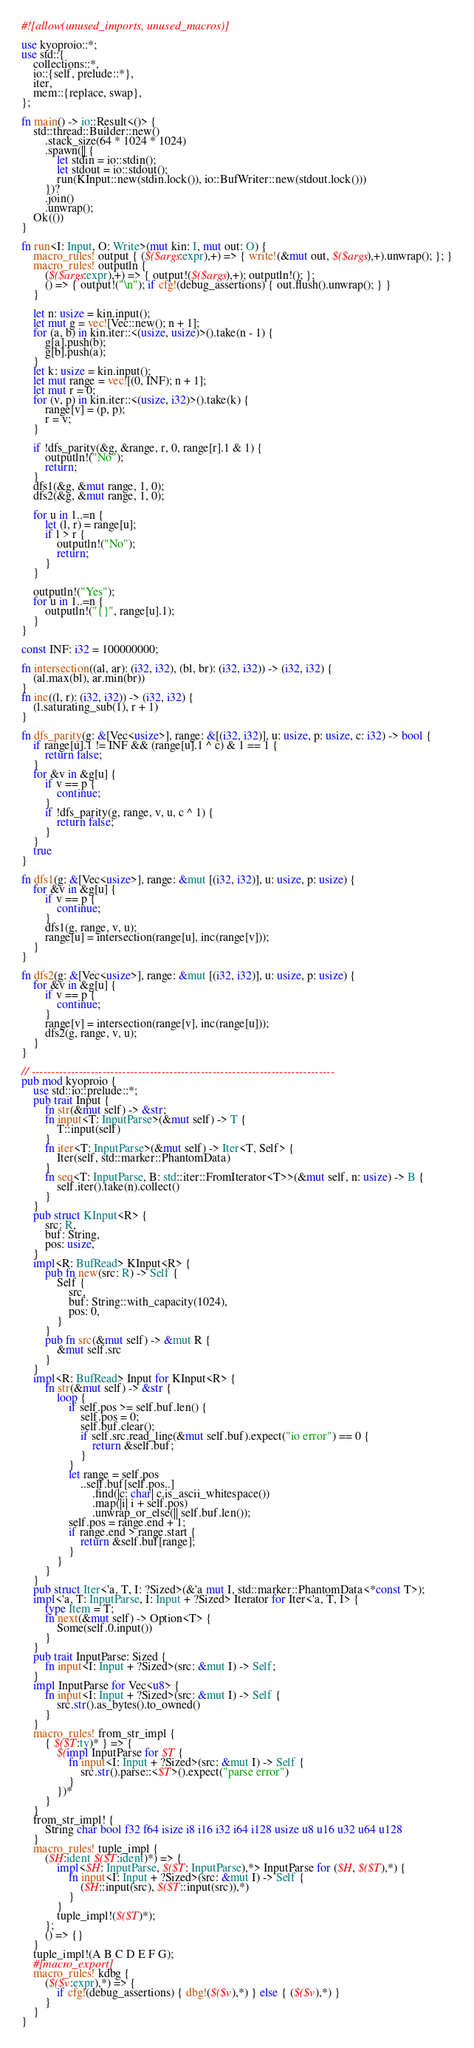Convert code to text. <code><loc_0><loc_0><loc_500><loc_500><_Rust_>#![allow(unused_imports, unused_macros)]

use kyoproio::*;
use std::{
    collections::*,
    io::{self, prelude::*},
    iter,
    mem::{replace, swap},
};

fn main() -> io::Result<()> {
    std::thread::Builder::new()
        .stack_size(64 * 1024 * 1024)
        .spawn(|| {
            let stdin = io::stdin();
            let stdout = io::stdout();
            run(KInput::new(stdin.lock()), io::BufWriter::new(stdout.lock()))
        })?
        .join()
        .unwrap();
    Ok(())
}

fn run<I: Input, O: Write>(mut kin: I, mut out: O) {
    macro_rules! output { ($($args:expr),+) => { write!(&mut out, $($args),+).unwrap(); }; }
    macro_rules! outputln {
        ($($args:expr),+) => { output!($($args),+); outputln!(); };
        () => { output!("\n"); if cfg!(debug_assertions) { out.flush().unwrap(); } }
    }

    let n: usize = kin.input();
    let mut g = vec![Vec::new(); n + 1];
    for (a, b) in kin.iter::<(usize, usize)>().take(n - 1) {
        g[a].push(b);
        g[b].push(a);
    }
    let k: usize = kin.input();
    let mut range = vec![(0, INF); n + 1];
    let mut r = 0;
    for (v, p) in kin.iter::<(usize, i32)>().take(k) {
        range[v] = (p, p);
        r = v;
    }

    if !dfs_parity(&g, &range, r, 0, range[r].1 & 1) {
        outputln!("No");
        return;
    }
    dfs1(&g, &mut range, 1, 0);
    dfs2(&g, &mut range, 1, 0);

    for u in 1..=n {
        let (l, r) = range[u];
        if l > r {
            outputln!("No");
            return;
        }
    }

    outputln!("Yes");
    for u in 1..=n {
        outputln!("{}", range[u].1);
    }
}

const INF: i32 = 100000000;

fn intersection((al, ar): (i32, i32), (bl, br): (i32, i32)) -> (i32, i32) {
    (al.max(bl), ar.min(br))
}
fn inc((l, r): (i32, i32)) -> (i32, i32) {
    (l.saturating_sub(1), r + 1)
}

fn dfs_parity(g: &[Vec<usize>], range: &[(i32, i32)], u: usize, p: usize, c: i32) -> bool {
    if range[u].1 != INF && (range[u].1 ^ c) & 1 == 1 {
        return false;
    }
    for &v in &g[u] {
        if v == p {
            continue;
        }
        if !dfs_parity(g, range, v, u, c ^ 1) {
            return false;
        }
    }
    true
}

fn dfs1(g: &[Vec<usize>], range: &mut [(i32, i32)], u: usize, p: usize) {
    for &v in &g[u] {
        if v == p {
            continue;
        }
        dfs1(g, range, v, u);
        range[u] = intersection(range[u], inc(range[v]));
    }
}

fn dfs2(g: &[Vec<usize>], range: &mut [(i32, i32)], u: usize, p: usize) {
    for &v in &g[u] {
        if v == p {
            continue;
        }
        range[v] = intersection(range[v], inc(range[u]));
        dfs2(g, range, v, u);
    }
}

// -----------------------------------------------------------------------------
pub mod kyoproio {
    use std::io::prelude::*;
    pub trait Input {
        fn str(&mut self) -> &str;
        fn input<T: InputParse>(&mut self) -> T {
            T::input(self)
        }
        fn iter<T: InputParse>(&mut self) -> Iter<T, Self> {
            Iter(self, std::marker::PhantomData)
        }
        fn seq<T: InputParse, B: std::iter::FromIterator<T>>(&mut self, n: usize) -> B {
            self.iter().take(n).collect()
        }
    }
    pub struct KInput<R> {
        src: R,
        buf: String,
        pos: usize,
    }
    impl<R: BufRead> KInput<R> {
        pub fn new(src: R) -> Self {
            Self {
                src,
                buf: String::with_capacity(1024),
                pos: 0,
            }
        }
        pub fn src(&mut self) -> &mut R {
            &mut self.src
        }
    }
    impl<R: BufRead> Input for KInput<R> {
        fn str(&mut self) -> &str {
            loop {
                if self.pos >= self.buf.len() {
                    self.pos = 0;
                    self.buf.clear();
                    if self.src.read_line(&mut self.buf).expect("io error") == 0 {
                        return &self.buf;
                    }
                }
                let range = self.pos
                    ..self.buf[self.pos..]
                        .find(|c: char| c.is_ascii_whitespace())
                        .map(|i| i + self.pos)
                        .unwrap_or_else(|| self.buf.len());
                self.pos = range.end + 1;
                if range.end > range.start {
                    return &self.buf[range];
                }
            }
        }
    }
    pub struct Iter<'a, T, I: ?Sized>(&'a mut I, std::marker::PhantomData<*const T>);
    impl<'a, T: InputParse, I: Input + ?Sized> Iterator for Iter<'a, T, I> {
        type Item = T;
        fn next(&mut self) -> Option<T> {
            Some(self.0.input())
        }
    }
    pub trait InputParse: Sized {
        fn input<I: Input + ?Sized>(src: &mut I) -> Self;
    }
    impl InputParse for Vec<u8> {
        fn input<I: Input + ?Sized>(src: &mut I) -> Self {
            src.str().as_bytes().to_owned()
        }
    }
    macro_rules! from_str_impl {
        { $($T:ty)* } => {
            $(impl InputParse for $T {
                fn input<I: Input + ?Sized>(src: &mut I) -> Self {
                    src.str().parse::<$T>().expect("parse error")
                }
            })*
        }
    }
    from_str_impl! {
        String char bool f32 f64 isize i8 i16 i32 i64 i128 usize u8 u16 u32 u64 u128
    }
    macro_rules! tuple_impl {
        ($H:ident $($T:ident)*) => {
            impl<$H: InputParse, $($T: InputParse),*> InputParse for ($H, $($T),*) {
                fn input<I: Input + ?Sized>(src: &mut I) -> Self {
                    ($H::input(src), $($T::input(src)),*)
                }
            }
            tuple_impl!($($T)*);
        };
        () => {}
    }
    tuple_impl!(A B C D E F G);
    #[macro_export]
    macro_rules! kdbg {
        ($($v:expr),*) => {
            if cfg!(debug_assertions) { dbg!($($v),*) } else { ($($v),*) }
        }
    }
}
</code> 